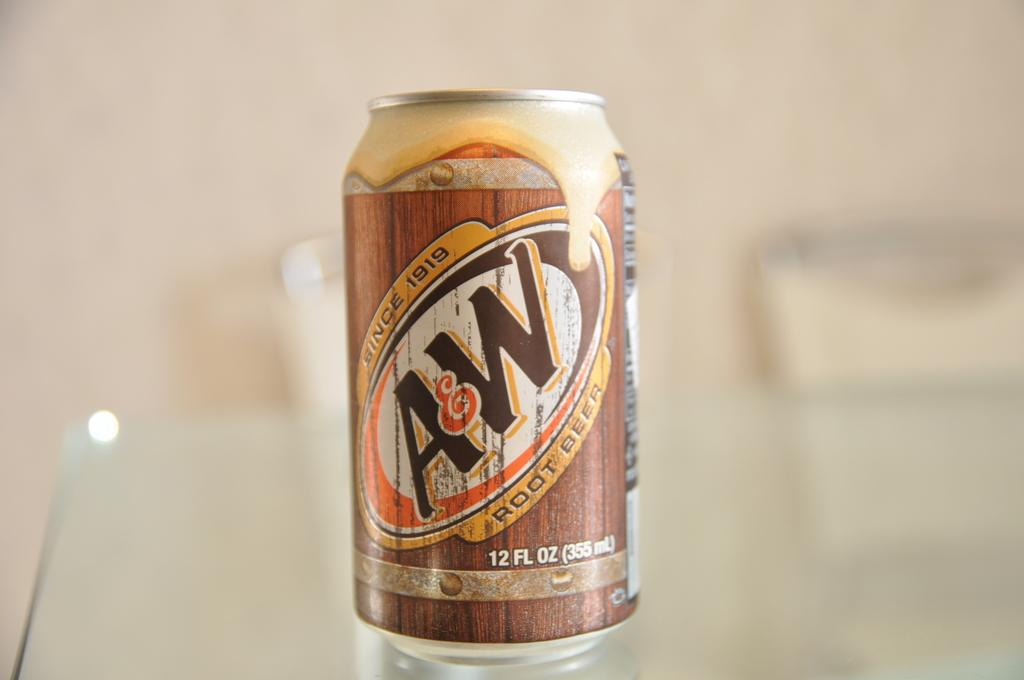<image>
Describe the image concisely. Root beer can which says A&W on the front. 